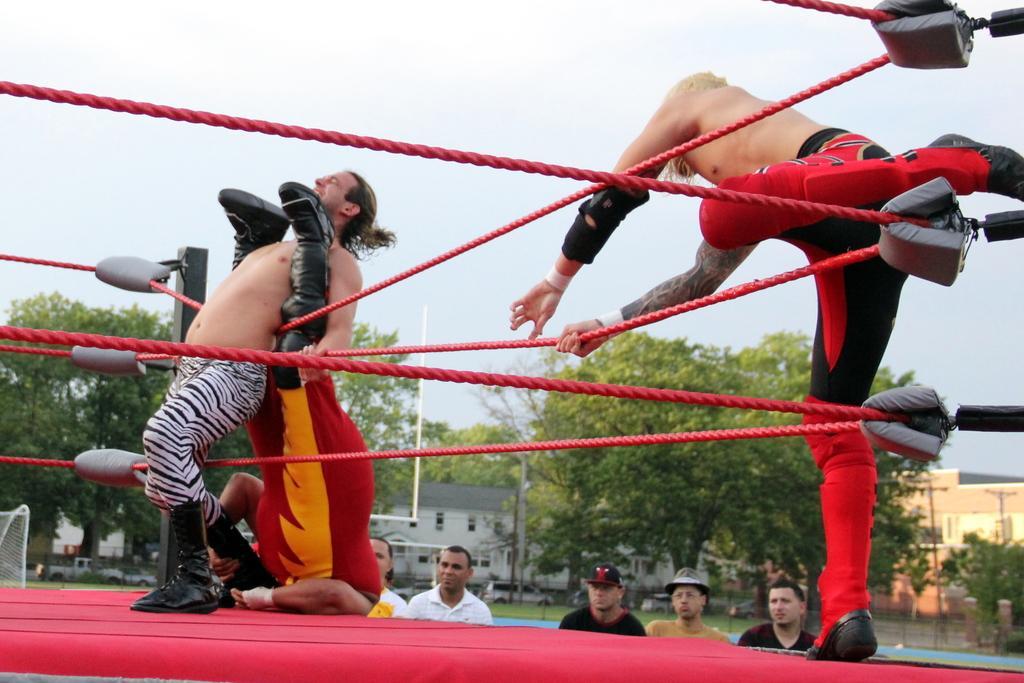How would you summarize this image in a sentence or two? In this image I can see three men are fighting on the boxing ring which is in red color. In the background there are few people looking at these men. In the background there are some buildings and trees. On the top of the image I can see the sky. 